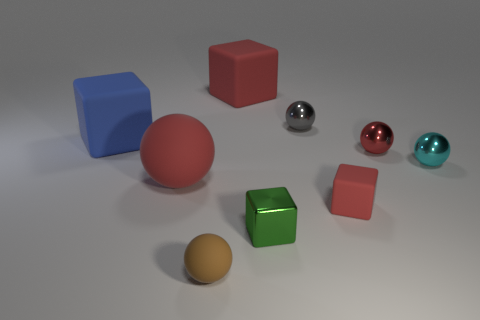Is the number of red things greater than the number of big gray metallic blocks?
Provide a succinct answer. Yes. How many small spheres are the same color as the small matte block?
Your answer should be very brief. 1. What is the color of the other small rubber object that is the same shape as the green object?
Provide a short and direct response. Red. What material is the thing that is right of the tiny green metallic object and behind the large blue matte block?
Offer a terse response. Metal. Is the red cube that is in front of the large blue cube made of the same material as the object that is right of the red metal object?
Make the answer very short. No. What is the size of the cyan sphere?
Give a very brief answer. Small. The gray thing that is the same shape as the tiny cyan thing is what size?
Make the answer very short. Small. What number of big red rubber cubes are in front of the cyan metallic thing?
Provide a short and direct response. 0. There is a shiny object in front of the cube to the right of the tiny shiny cube; what color is it?
Give a very brief answer. Green. Are there the same number of shiny things that are behind the tiny cyan sphere and large red objects that are behind the blue object?
Offer a very short reply. No. 